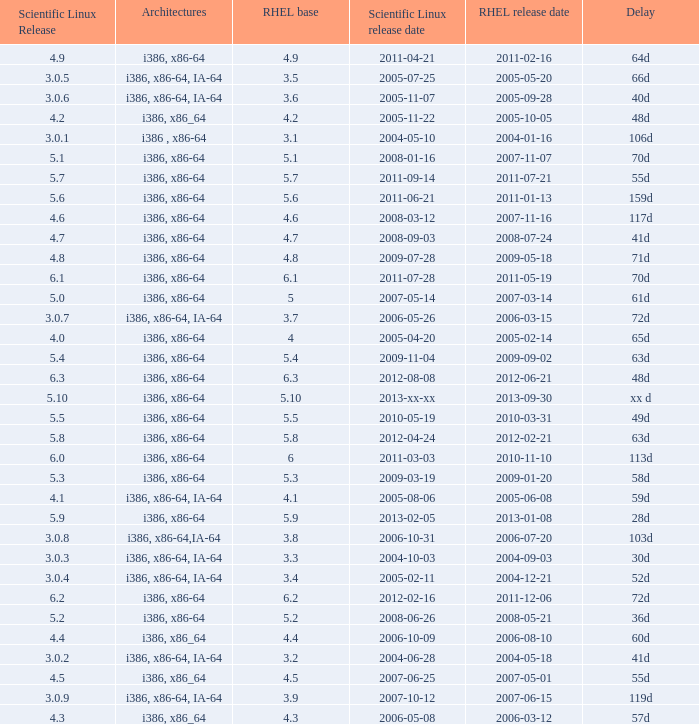4? 2004-12-21. 